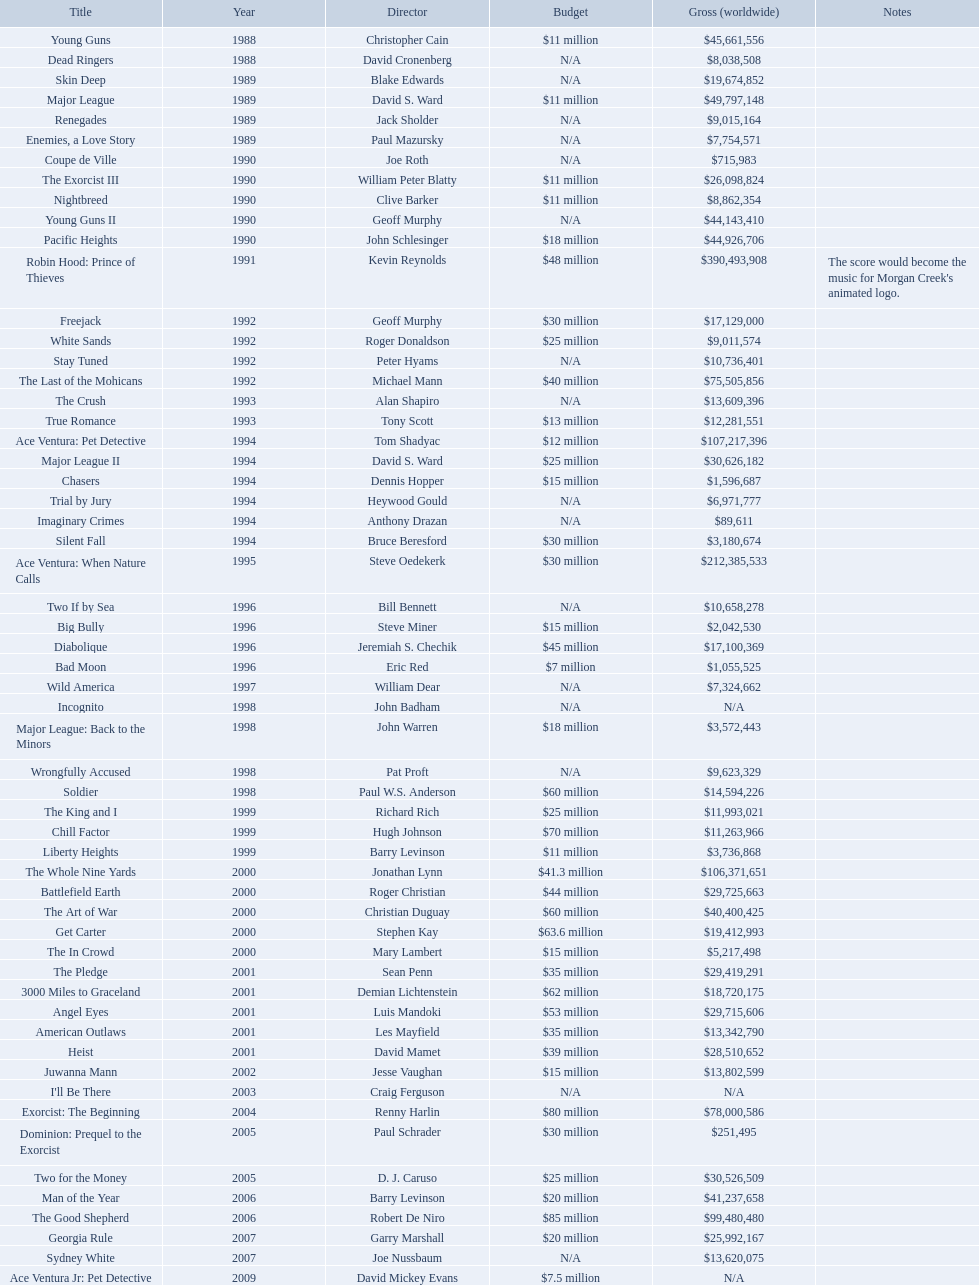What was the only movie with a 48 million dollar budget? Robin Hood: Prince of Thieves. 